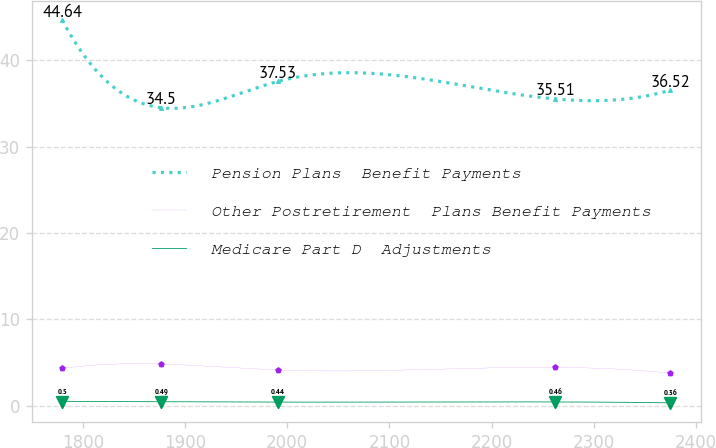Convert chart to OTSL. <chart><loc_0><loc_0><loc_500><loc_500><line_chart><ecel><fcel>Pension Plans  Benefit Payments<fcel>Other Postretirement  Plans Benefit Payments<fcel>Medicare Part D  Adjustments<nl><fcel>1779.7<fcel>44.64<fcel>4.33<fcel>0.5<nl><fcel>1876.34<fcel>34.5<fcel>4.84<fcel>0.49<nl><fcel>1990.49<fcel>37.53<fcel>4.16<fcel>0.44<nl><fcel>2262.24<fcel>35.51<fcel>4.46<fcel>0.46<nl><fcel>2374.84<fcel>36.52<fcel>3.78<fcel>0.36<nl></chart> 